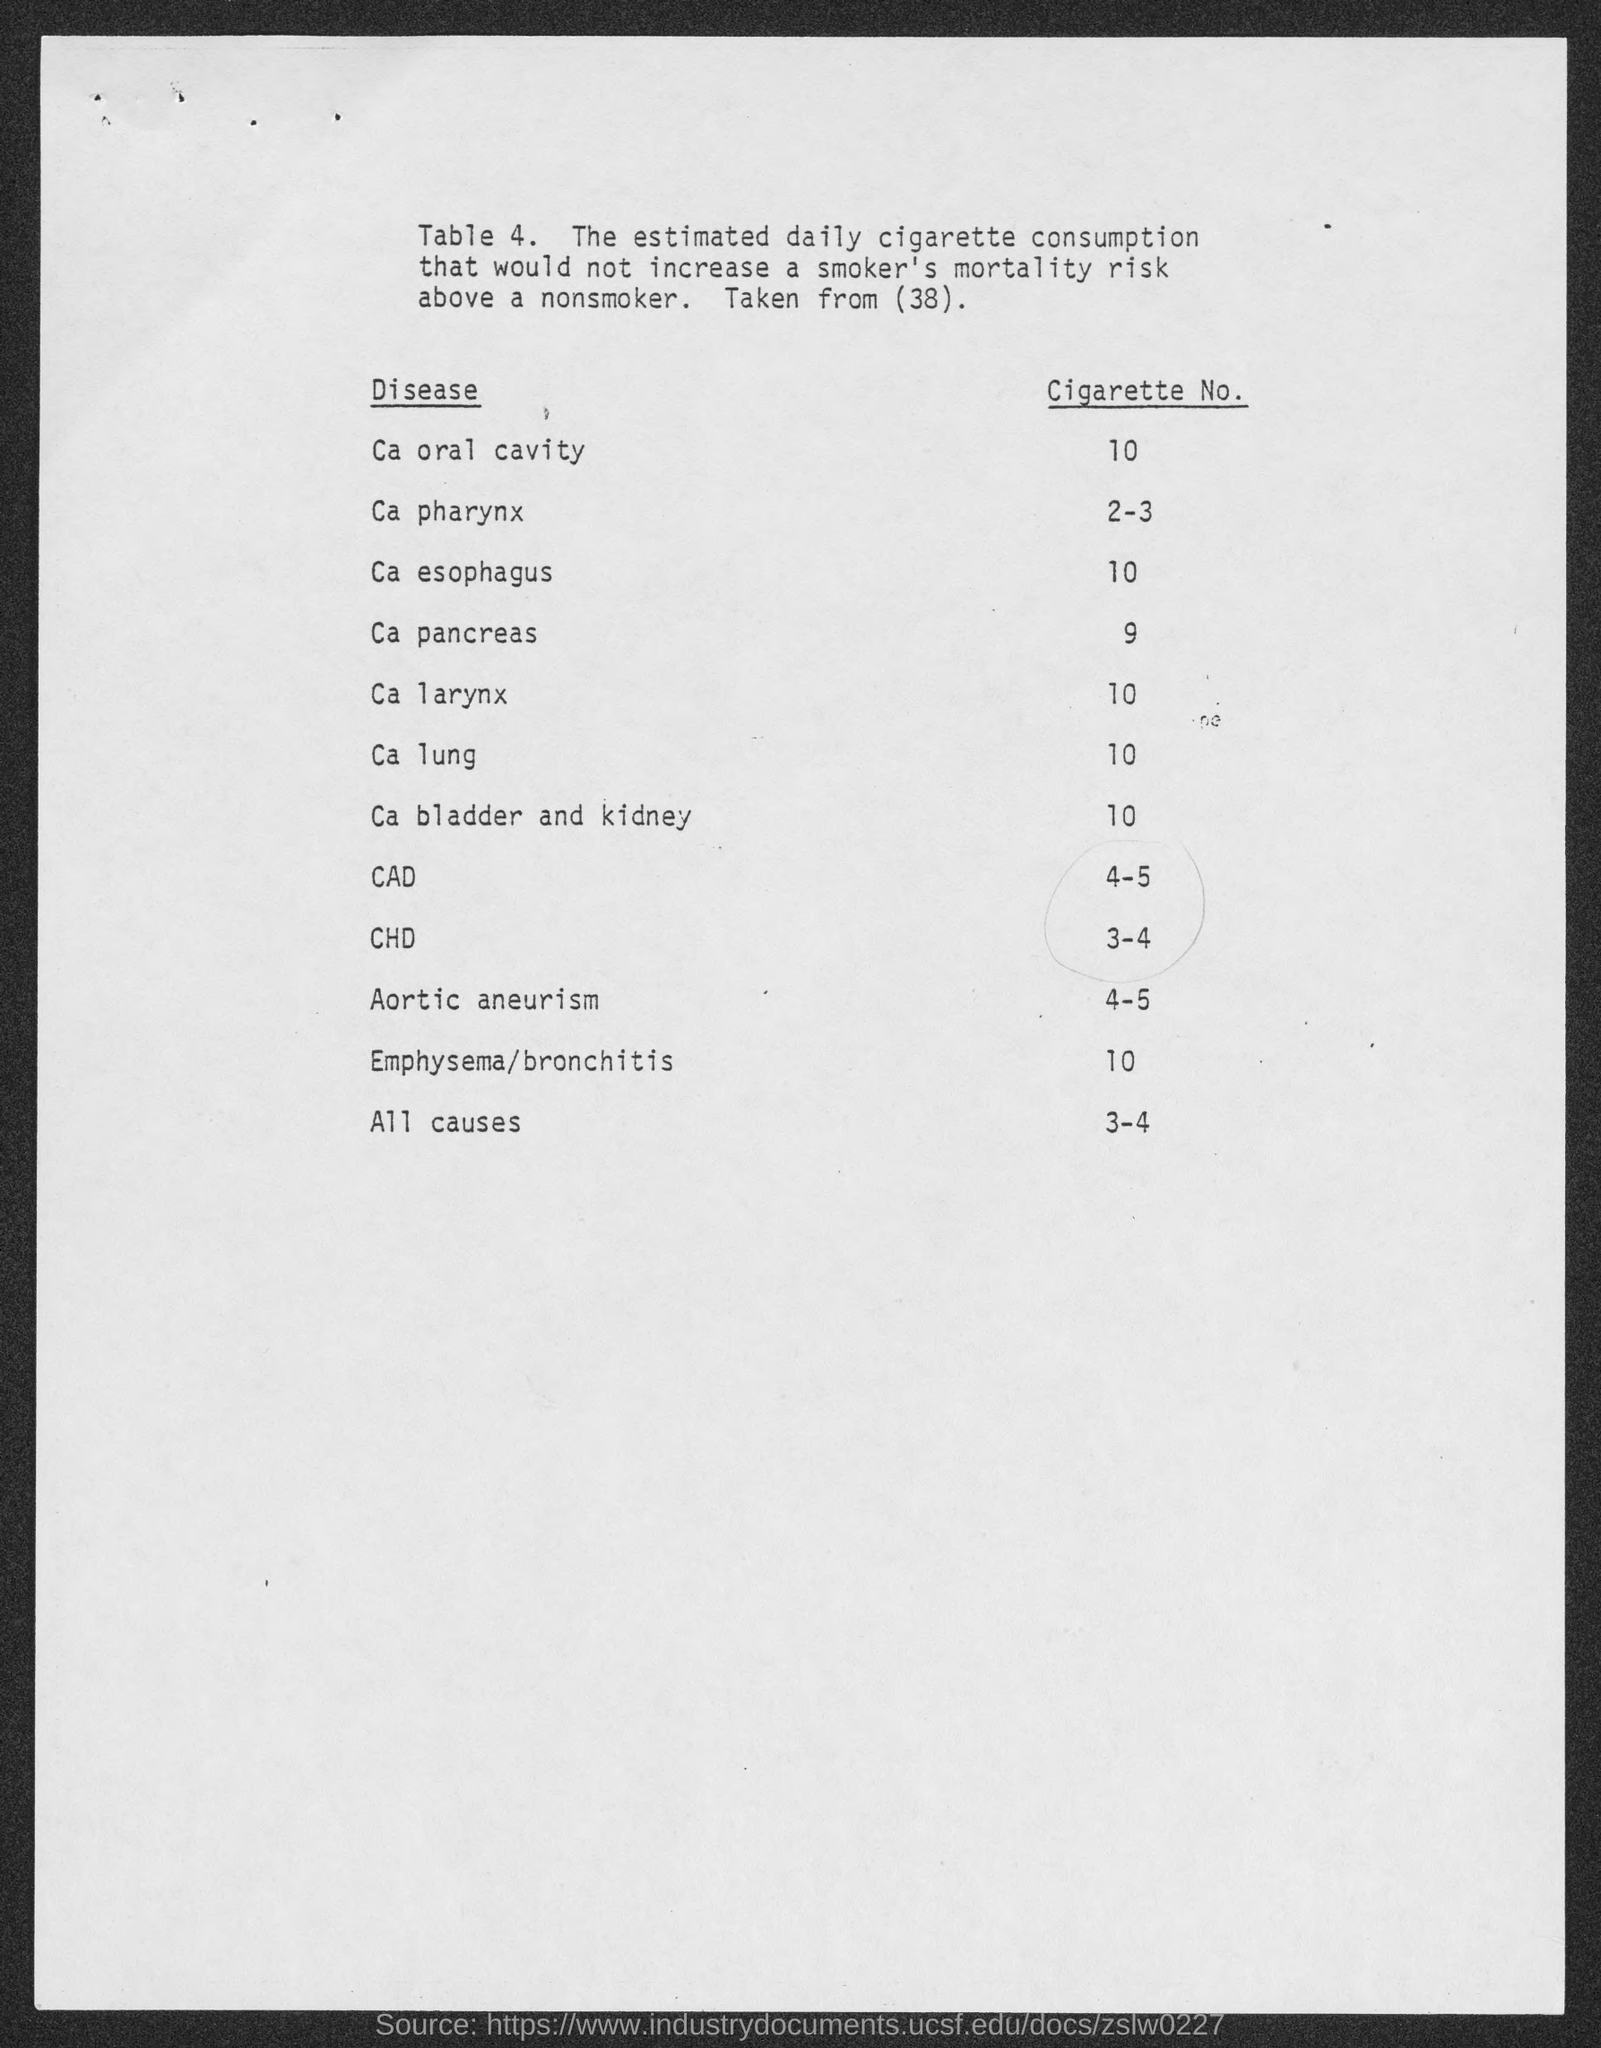What is the cigarette no. for the ca oral cavity as mentioned in the given table ?
Keep it short and to the point. 10. What is the cigarette no. for the ca pharynx as mentioned in the given table ?
Your answer should be compact. 2-3. What is the cigarette no. for the ca esophagus  as mentioned in the given table ?
Keep it short and to the point. 10. What is the cigarette no. for the cad as mentioned in the given table ?
Give a very brief answer. 4-5. What is the cigarette no. for all causes as mentioned in the given table ?
Your answer should be very brief. 3-4. What is the name of the disease for the cigarette no. 9 ?
Your answer should be compact. Ca pancreas. What is the name of the disease for the cigarette no. 2-3 ?
Your response must be concise. Ca pharynx. What is the cigarette no. for the ca lung as mentioned in the given table ?
Give a very brief answer. 10. What is the cigarette no. for ca bladder and kidney as mentioned in the given table ?
Your response must be concise. 10. What is the cigarette no. for aortic aneurism as mentioned in the given table ?
Offer a terse response. 4-5. 